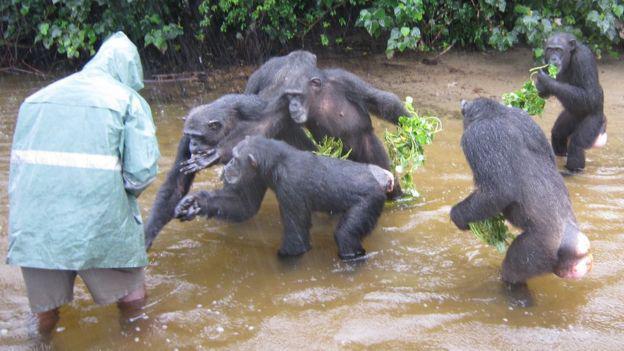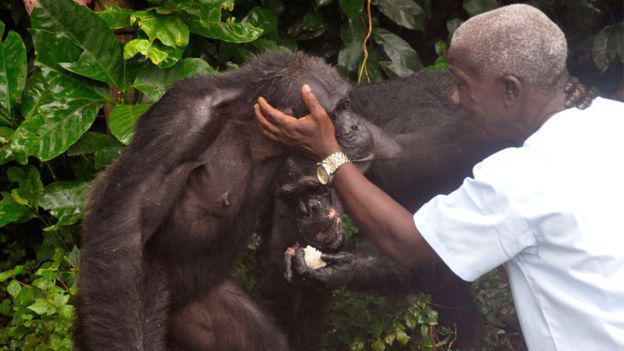The first image is the image on the left, the second image is the image on the right. Given the left and right images, does the statement "There is at least four chimpanzees in the right image." hold true? Answer yes or no. No. The first image is the image on the left, the second image is the image on the right. Assess this claim about the two images: "Each image shows one person interacting with at least one chimp, and one image shows a black man with his hand on a chimp's head.". Correct or not? Answer yes or no. Yes. 